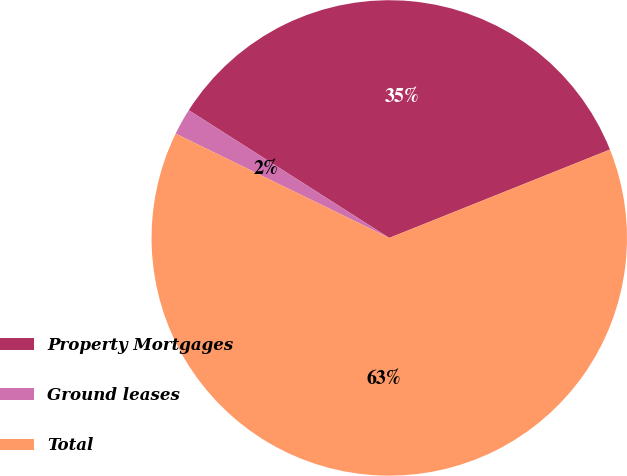Convert chart to OTSL. <chart><loc_0><loc_0><loc_500><loc_500><pie_chart><fcel>Property Mortgages<fcel>Ground leases<fcel>Total<nl><fcel>34.91%<fcel>1.8%<fcel>63.29%<nl></chart> 